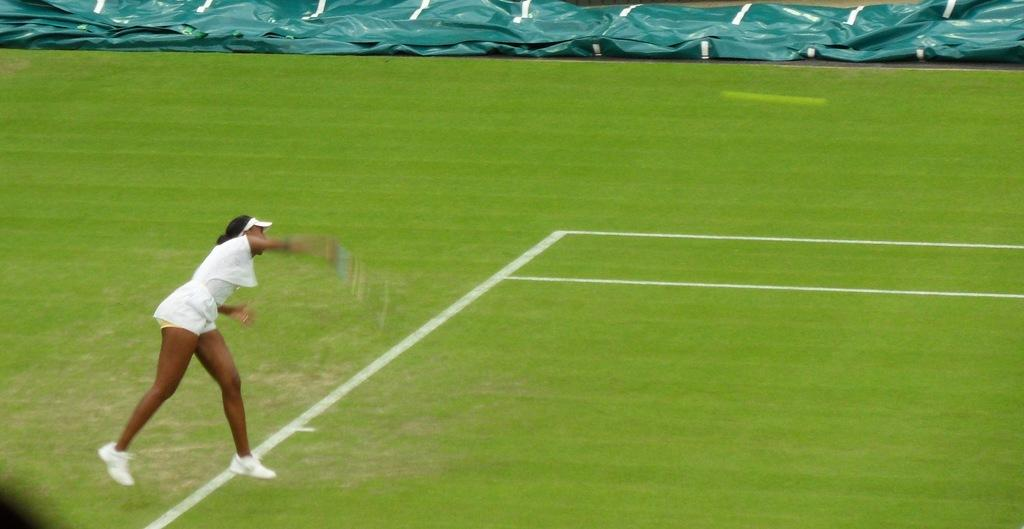Who is present in the image? There is a woman in the image. What is the woman wearing? The woman is wearing a white dress, a cap, and shoes. What can be seen in the background of the image? There are white color lines, grass, and green color objects in the background of the image. What type of beef is being cooked on the pipe in the image? There is no beef or pipe present in the image. How does the woman's nerve affect her posture in the image? There is no mention of the woman's nerve in the image, and her posture cannot be determined from the provided facts. 